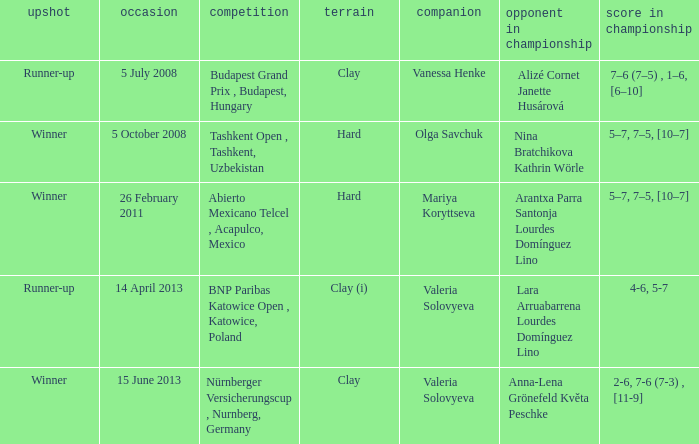Name the outcome that had an opponent in final of nina bratchikova kathrin wörle Winner. 